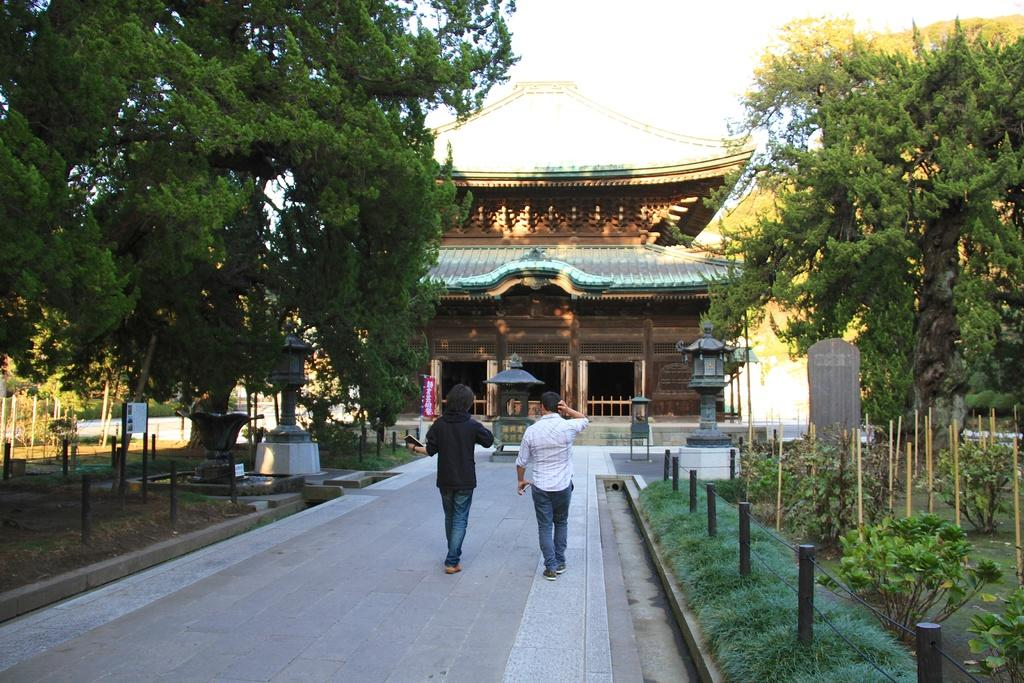What type of natural elements can be seen in the image? There are trees in the image. What type of man-made structure is present in the image? There is a building in the image. What are the people in the image doing? There are people walking in the image. What is written or displayed on the board in the image? There is a board with text in the image. What type of vegetation is on the ground in the image? There are plants on the ground in the image. How would you describe the weather in the image? The sky is cloudy in the image. What color is the silver pig being offered in the image? There is no silver pig being offered in the image; it does not contain any pigs or silver objects. 